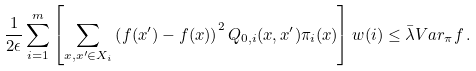<formula> <loc_0><loc_0><loc_500><loc_500>\frac { 1 } { 2 \epsilon } \sum _ { i = 1 } ^ { m } \left [ \sum _ { x , x ^ { \prime } \in X _ { i } } \left ( f ( x ^ { \prime } ) - f ( x ) \right ) ^ { 2 } Q _ { 0 , i } ( x , x ^ { \prime } ) \pi _ { i } ( x ) \right ] w ( i ) \leq \bar { \lambda } V a r _ { \pi } f \, .</formula> 